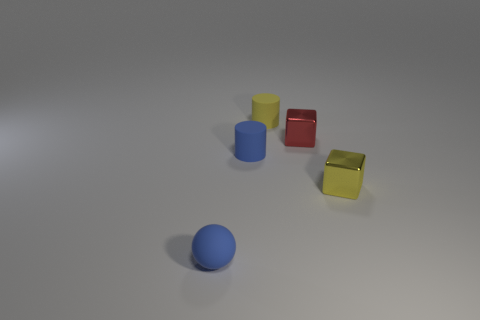Add 5 blue matte balls. How many objects exist? 10 Subtract all spheres. How many objects are left? 4 Add 3 cylinders. How many cylinders exist? 5 Subtract 0 purple balls. How many objects are left? 5 Subtract all big cyan things. Subtract all yellow matte things. How many objects are left? 4 Add 3 small blocks. How many small blocks are left? 5 